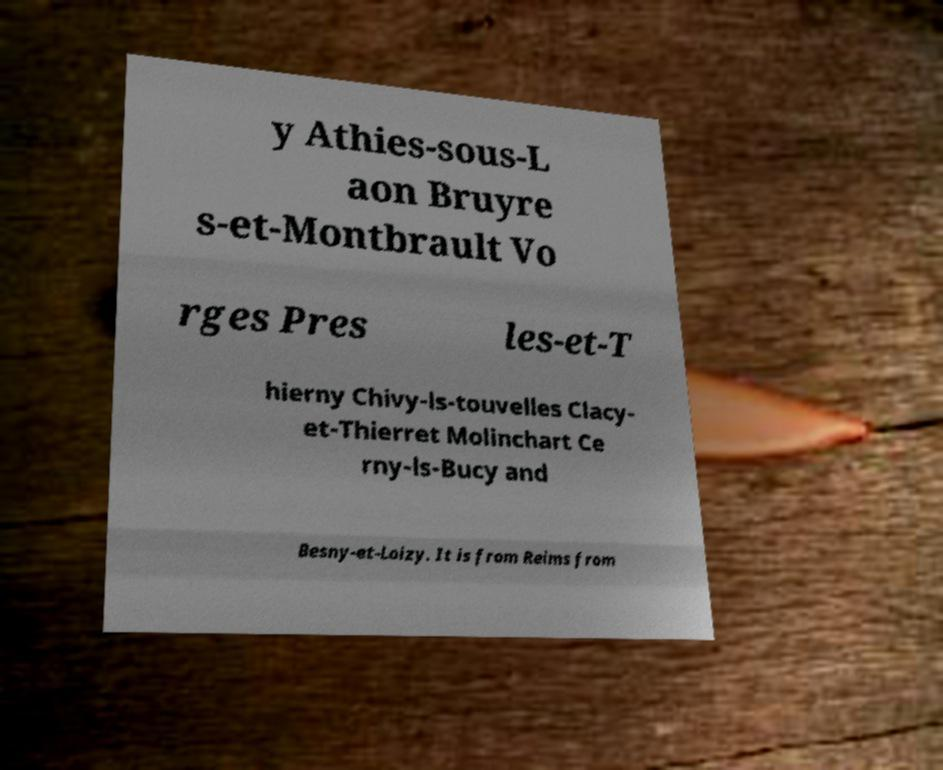There's text embedded in this image that I need extracted. Can you transcribe it verbatim? y Athies-sous-L aon Bruyre s-et-Montbrault Vo rges Pres les-et-T hierny Chivy-ls-touvelles Clacy- et-Thierret Molinchart Ce rny-ls-Bucy and Besny-et-Loizy. It is from Reims from 